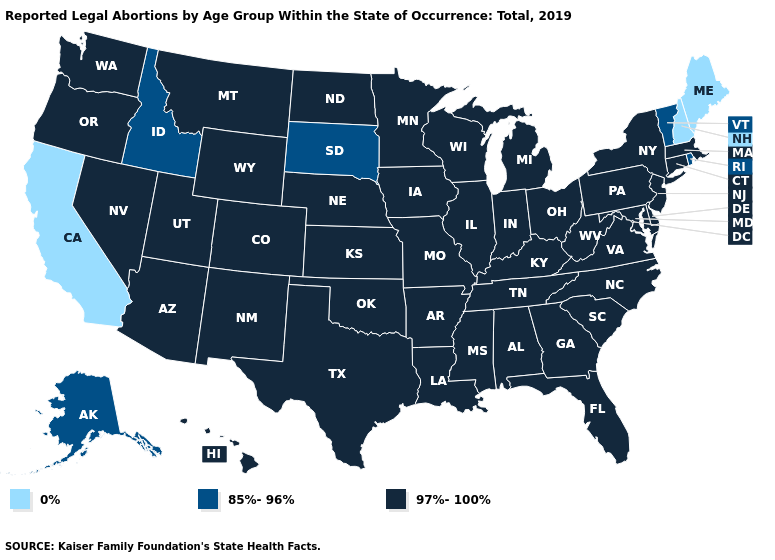What is the value of Virginia?
Write a very short answer. 97%-100%. What is the value of Arkansas?
Concise answer only. 97%-100%. What is the value of Tennessee?
Be succinct. 97%-100%. What is the value of Illinois?
Answer briefly. 97%-100%. What is the value of Oklahoma?
Quick response, please. 97%-100%. Name the states that have a value in the range 97%-100%?
Short answer required. Alabama, Arizona, Arkansas, Colorado, Connecticut, Delaware, Florida, Georgia, Hawaii, Illinois, Indiana, Iowa, Kansas, Kentucky, Louisiana, Maryland, Massachusetts, Michigan, Minnesota, Mississippi, Missouri, Montana, Nebraska, Nevada, New Jersey, New Mexico, New York, North Carolina, North Dakota, Ohio, Oklahoma, Oregon, Pennsylvania, South Carolina, Tennessee, Texas, Utah, Virginia, Washington, West Virginia, Wisconsin, Wyoming. Name the states that have a value in the range 0%?
Quick response, please. California, Maine, New Hampshire. Name the states that have a value in the range 97%-100%?
Be succinct. Alabama, Arizona, Arkansas, Colorado, Connecticut, Delaware, Florida, Georgia, Hawaii, Illinois, Indiana, Iowa, Kansas, Kentucky, Louisiana, Maryland, Massachusetts, Michigan, Minnesota, Mississippi, Missouri, Montana, Nebraska, Nevada, New Jersey, New Mexico, New York, North Carolina, North Dakota, Ohio, Oklahoma, Oregon, Pennsylvania, South Carolina, Tennessee, Texas, Utah, Virginia, Washington, West Virginia, Wisconsin, Wyoming. Does the map have missing data?
Be succinct. No. Name the states that have a value in the range 85%-96%?
Be succinct. Alaska, Idaho, Rhode Island, South Dakota, Vermont. Among the states that border Iowa , which have the highest value?
Give a very brief answer. Illinois, Minnesota, Missouri, Nebraska, Wisconsin. Which states have the lowest value in the Northeast?
Quick response, please. Maine, New Hampshire. How many symbols are there in the legend?
Short answer required. 3. Among the states that border California , which have the highest value?
Quick response, please. Arizona, Nevada, Oregon. 